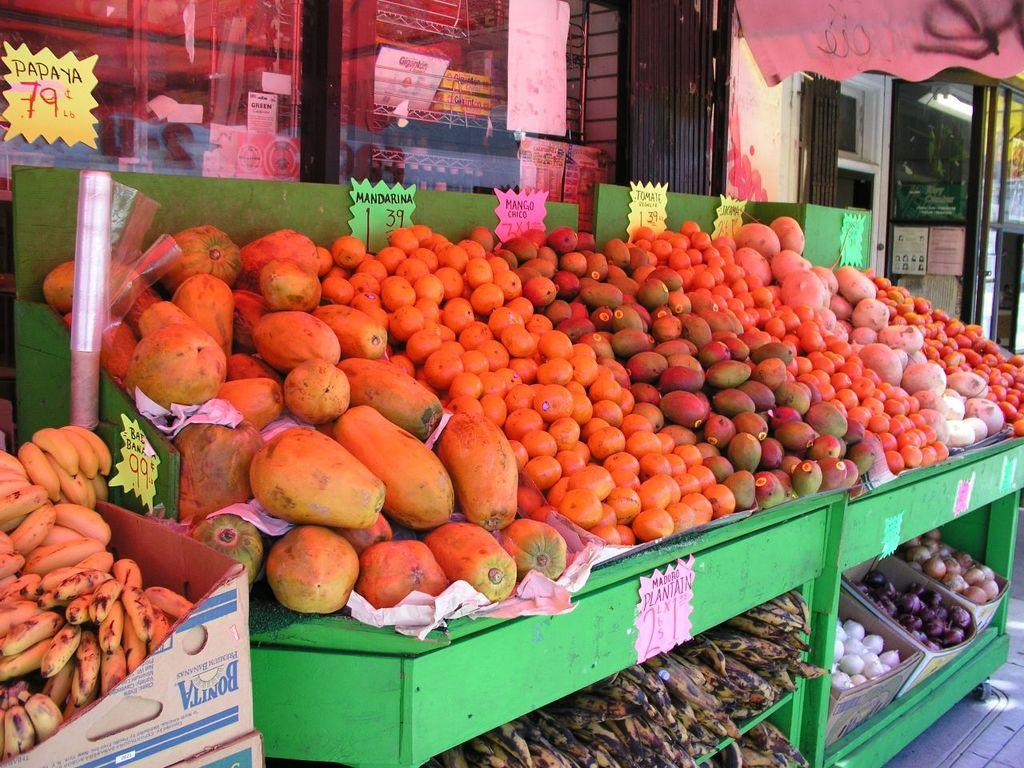What type of establishment is shown in the image? There is a store in the image. What can be seen attached to the mirrors in the store? Pipes are attached to mirrors in the store. How can customers determine the cost of items in the store? Price tags are present in the store. What types of food items are available in the store? There are different types of fruits and vegetables arranged in baskets in the store. How many brothers does the store owner have in the image? There is no information about the store owner or their family members in the image. 